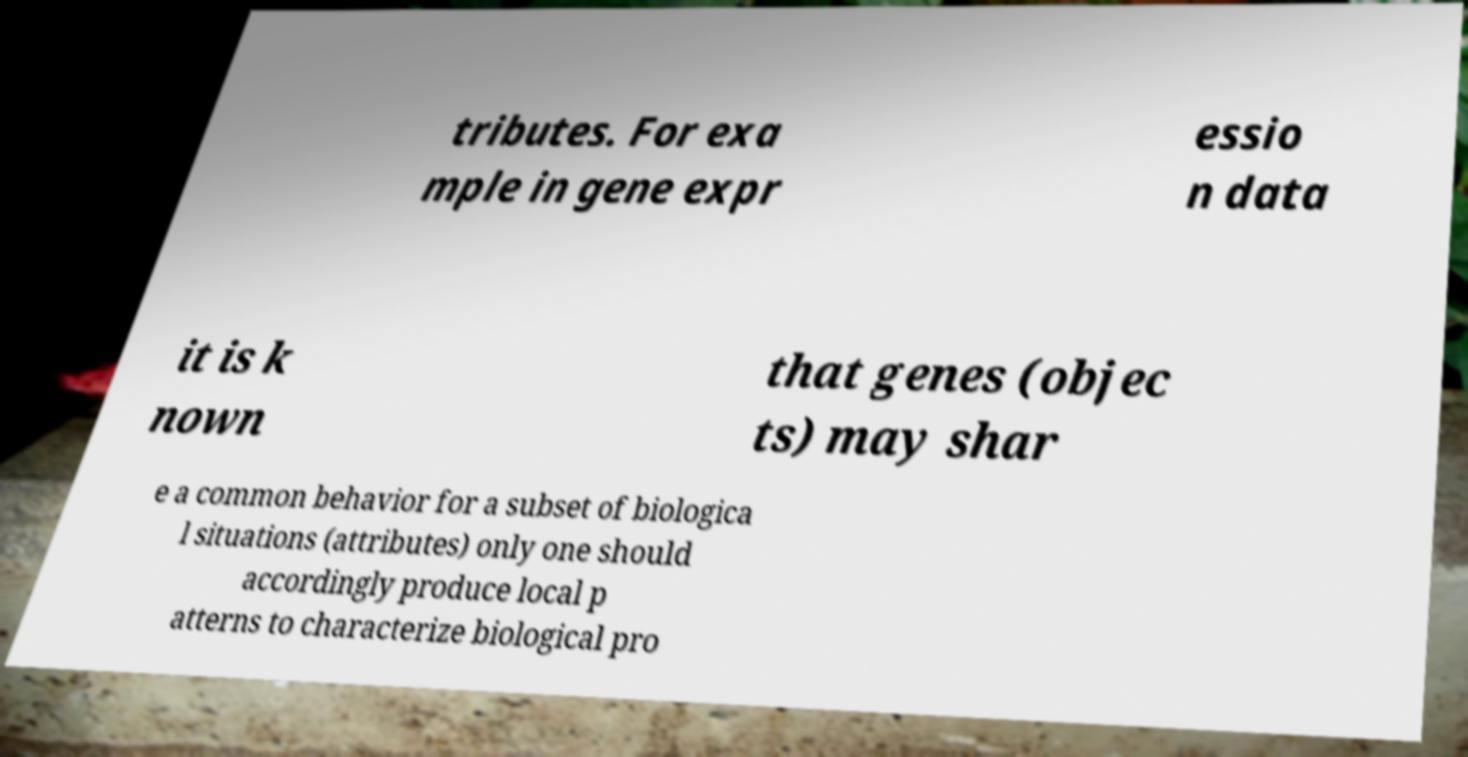Could you extract and type out the text from this image? tributes. For exa mple in gene expr essio n data it is k nown that genes (objec ts) may shar e a common behavior for a subset of biologica l situations (attributes) only one should accordingly produce local p atterns to characterize biological pro 